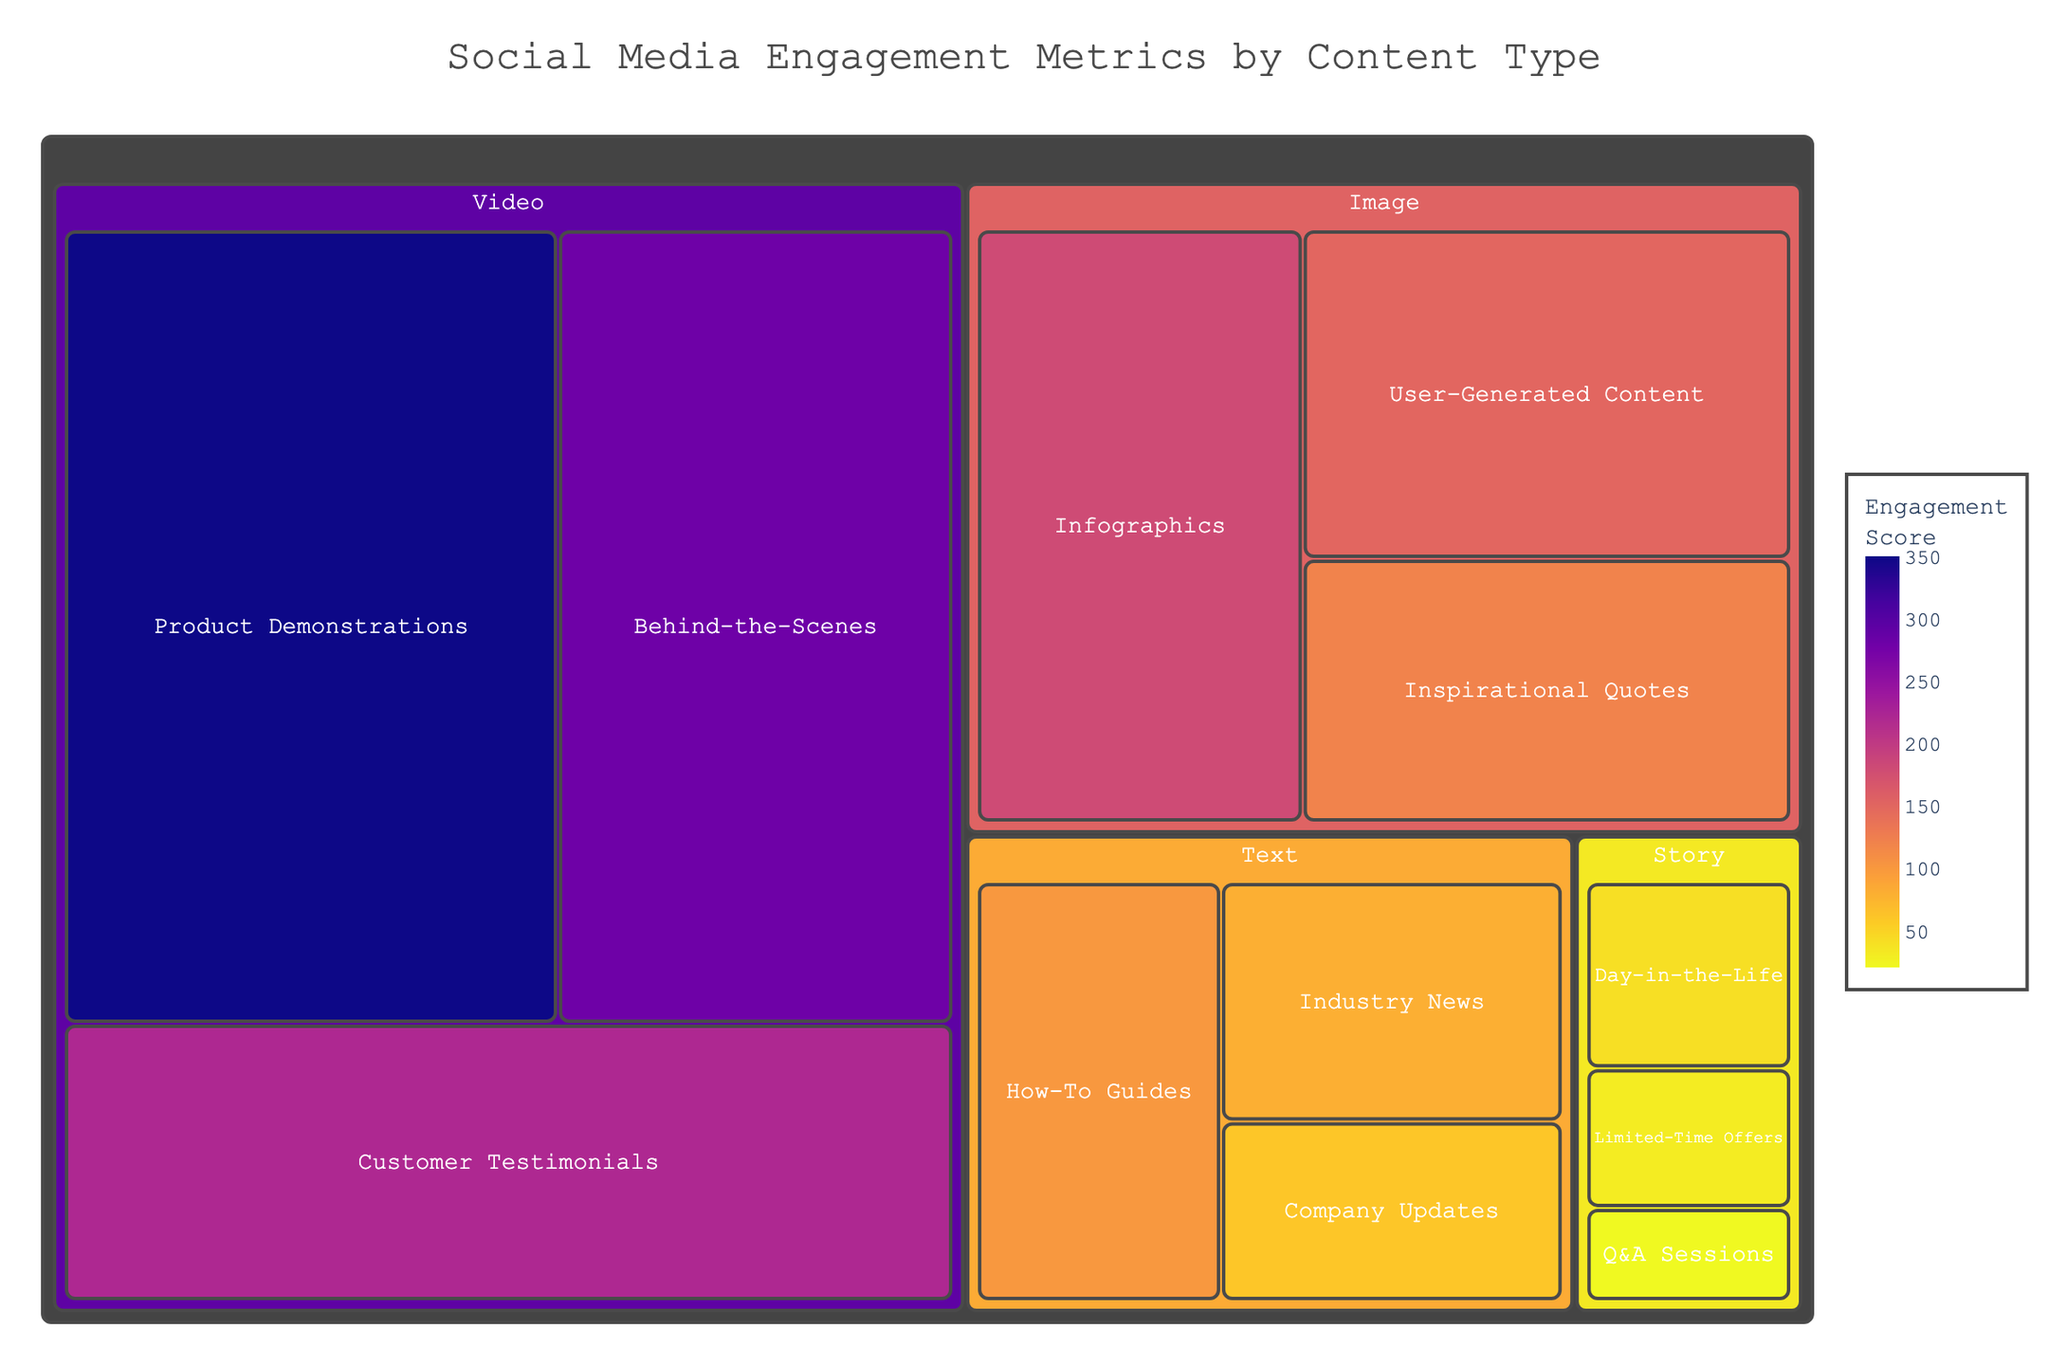What's the title of the figure? The title is typically the most prominent text, often located at the top of the figure. In this case, the title is displayed at the top-center of the treemap.
Answer: Social Media Engagement Metrics by Content Type How many different categories are there? Each primary block in a treemap represents a category. By counting these blocks, we can determine the number of categories.
Answer: 4 Which content type has the highest engagement score? The color intensity and size of the blocks in a treemap represent values. By identifying the largest and darkest block, we can determine the content type with the highest score.
Answer: Product Demonstrations What is the engagement score for the content type 'Industry News'? By looking at the block labeled 'Industry News', we can directly read the engagement score from the annotation or tooltip.
Answer: 80 What is the total engagement score for 'Video' content? To find the total engagement score for 'Video' content, we sum the engagement scores of all its subtypes: 350 (Product Demonstrations) + 280 (Behind-the-Scenes) + 220 (Customer Testimonials).
Answer: 850 Which content category has the lowest total engagement score? We calculate the sum of engagement scores for each category and compare them. 'Story' has the engagement scores: 40 (Day-in-the-Life) + 30 (Limited-Time Offers) + 20 (Q&A Sessions), which totals to 90. This is the lowest compared to other categories.
Answer: Story How does the engagement score for 'Infographics' compare to 'User-Generated Content'? By examining the blocks for both content types and comparing their sizes and values, we can determine the difference in their engagement scores: 'Infographics' has 180, and 'User-Generated Content' has 150.
Answer: Infographics has a higher score than User-Generated Content by 30 Which 'Text' content type has the highest engagement score? By looking at the sub-blocks under the 'Text' category and identifying the largest/darkest block, we find the one with the highest engagement score.
Answer: How-To Guides What is the average engagement score for the 'Story' category? We calculate the average by summing up all the engagement scores for the 'Story' category (40 + 30 + 20 = 90) and dividing by the number of content types (3).
Answer: 30 What proportion of the total engagement score is accounted for by 'Video' content? First, sum the engagement scores for all categories: (850 for Video + 450 for Image + 240 for Text + 90 for Story = 1630). Then, calculate the proportion for 'Video': 850 / 1630 ≈ 0.521.
Answer: 52.1% 